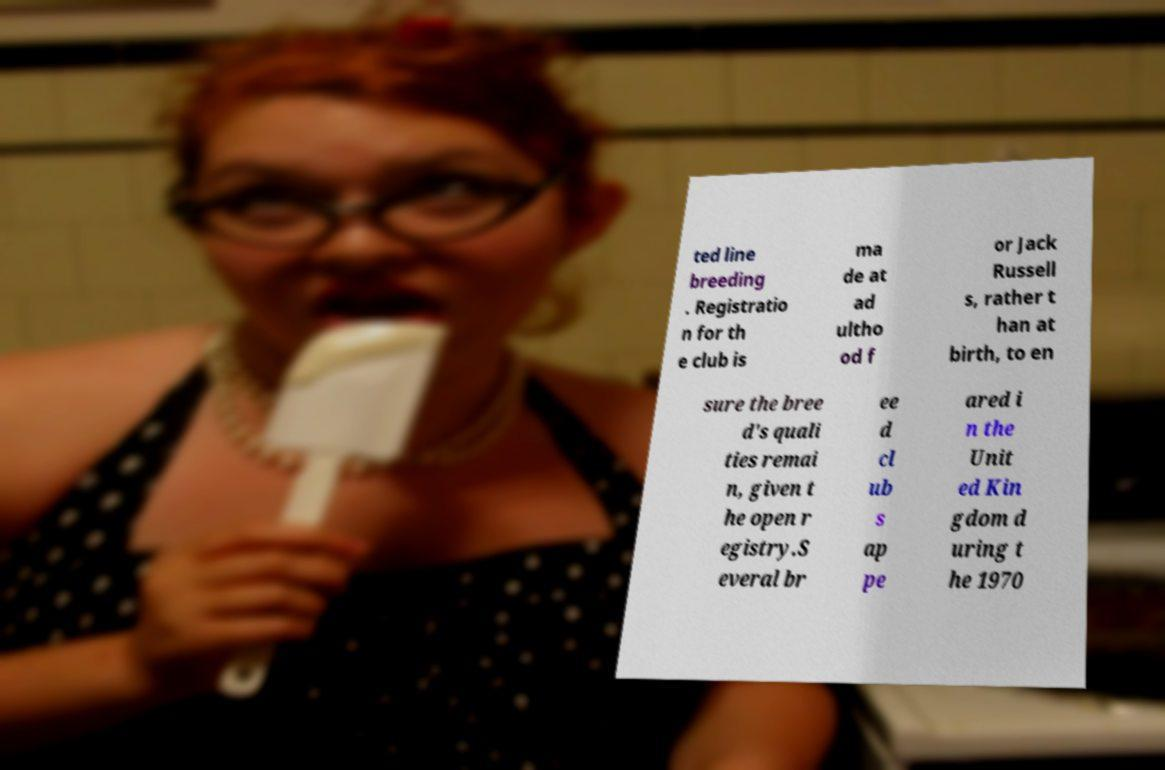There's text embedded in this image that I need extracted. Can you transcribe it verbatim? ted line breeding . Registratio n for th e club is ma de at ad ultho od f or Jack Russell s, rather t han at birth, to en sure the bree d's quali ties remai n, given t he open r egistry.S everal br ee d cl ub s ap pe ared i n the Unit ed Kin gdom d uring t he 1970 